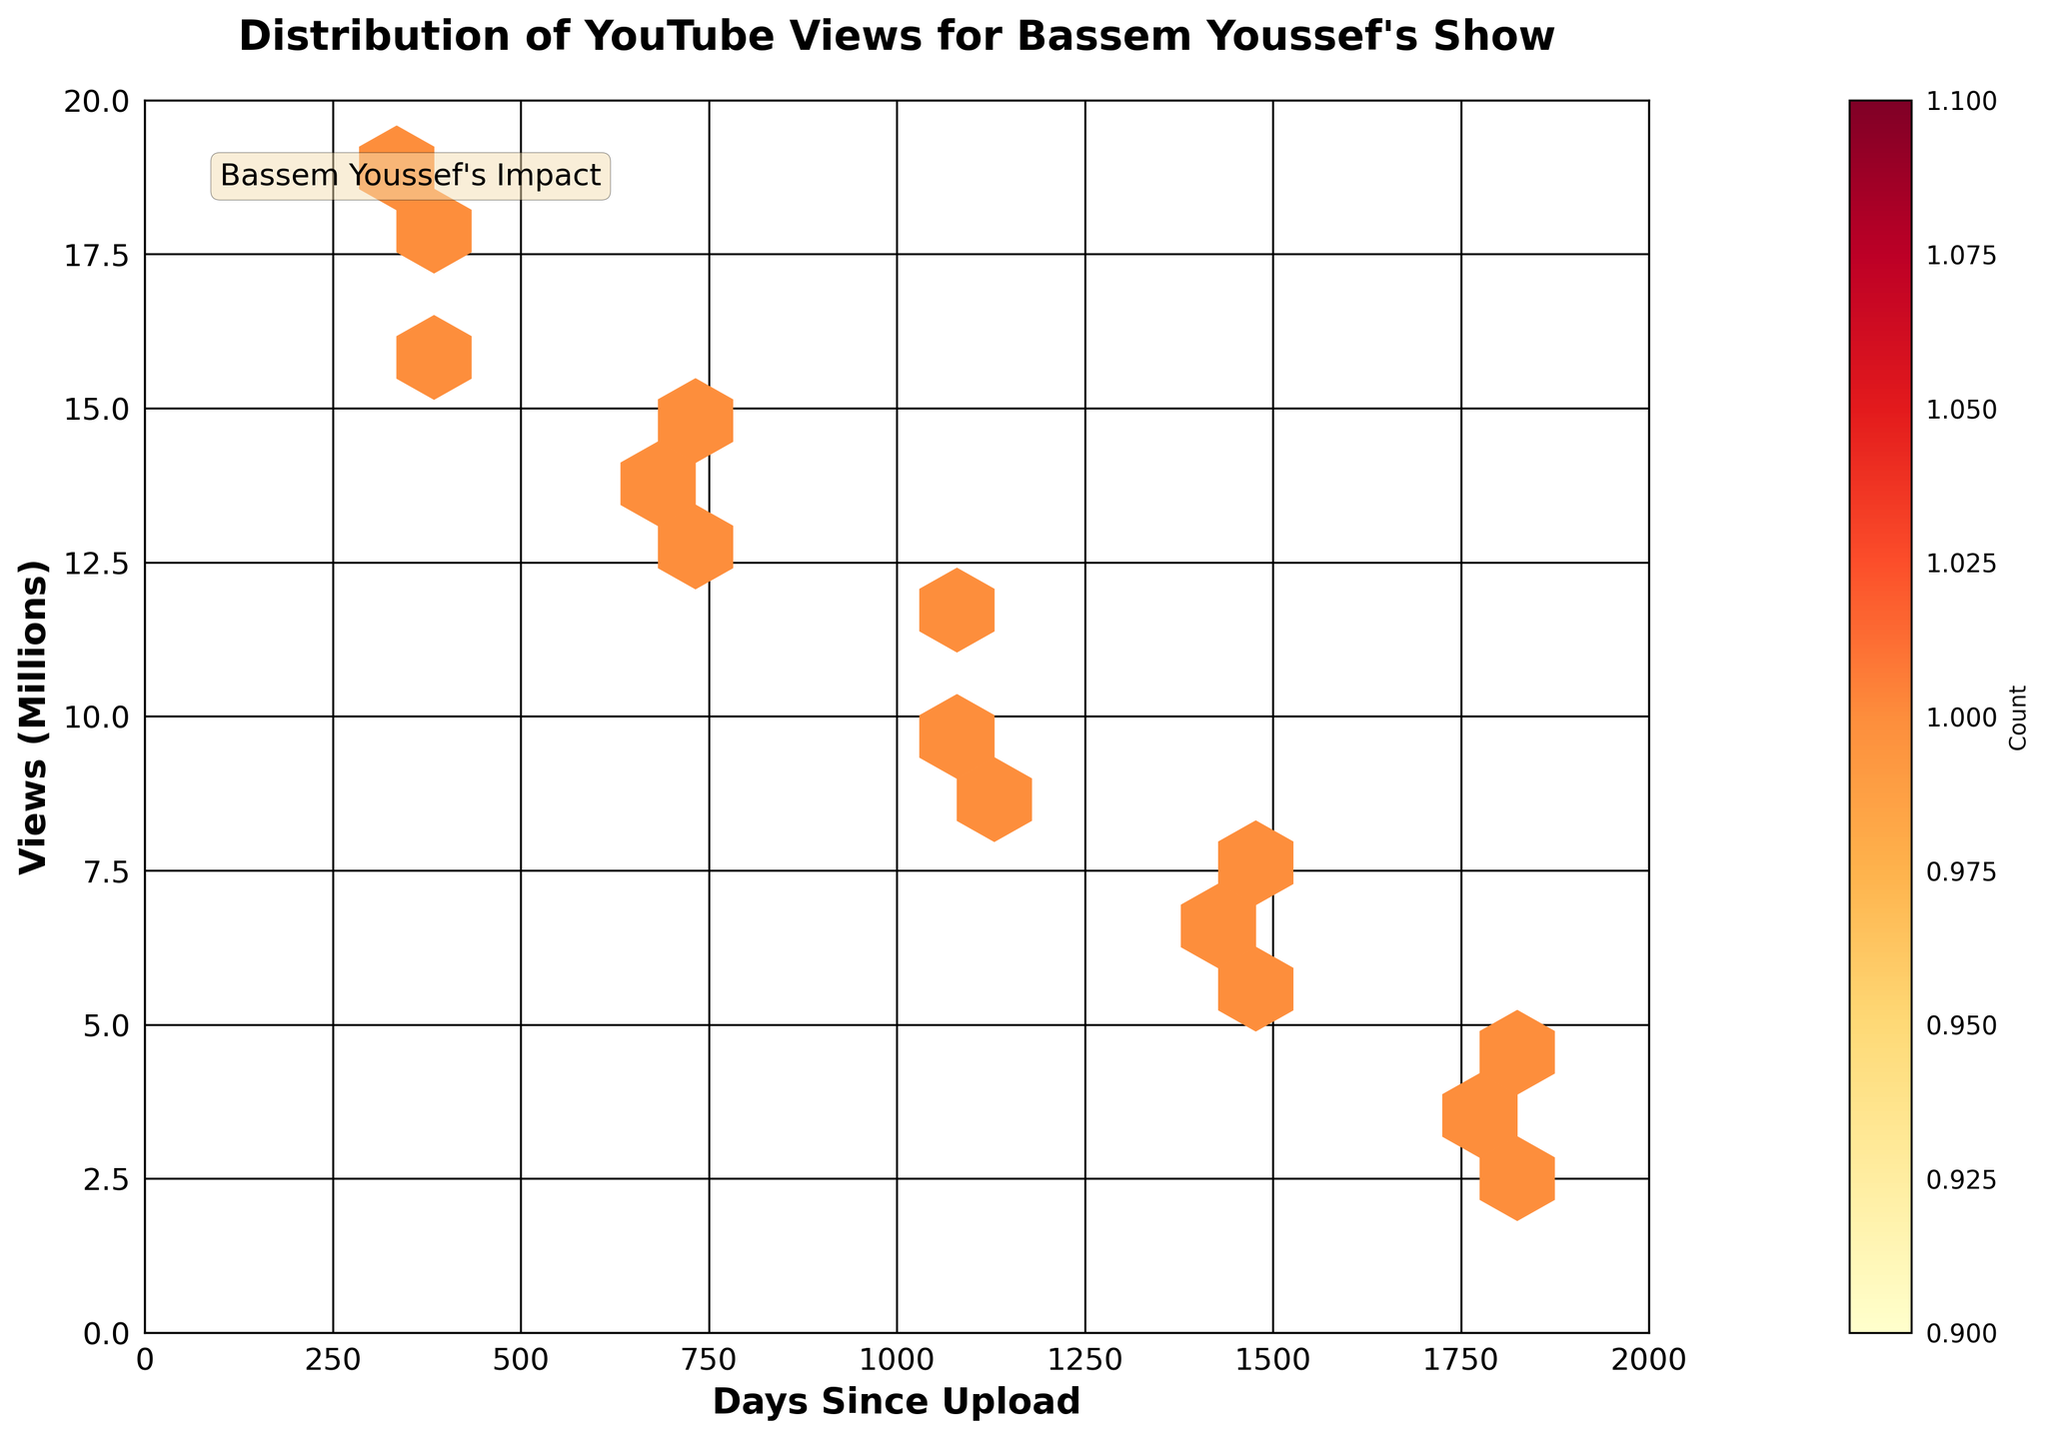What does the title of the plot say? The title of the plot is located at the top and provides a concise description of what the plot represents. It reads "Distribution of YouTube Views for Bassem Youssef's Show."
Answer: Distribution of YouTube Views for Bassem Youssef's Show What are the labels of the x and y axes? The labels of the x and y axes are located along the respective axes. The x-axis is labeled "Days Since Upload," and the y-axis is labeled "Views (Millions)."
Answer: Days Since Upload, Views (Millions) What does the color gradient on the plot represent? The color gradient on the hexbin plot indicates the density of data points in each hexagonal bin. It ranges from yellow, representing fewer points, to red, representing more points.
Answer: Density of data points Which season likely has episodes with the highest YouTube views? By observing the y-axis, we can see that the episodes with views ranging from 16.3 to 18.9 million are likely found in season 5, given the higher view numbers near the top of the plot.
Answer: Season 5 What is the range of the x-axis, and what does it signify? The x-axis ranges from 0 to 2000, which signifies the number of days since each episode was uploaded.
Answer: 0 to 2000 days Are there any clusters of episodes with similar views within the first 1000 days? By observing the plot, there are clusters of episodes with views between approximately 8.0 and 15.0 million views within the first 1000 days. This is signified by the dense regions of hexagons.
Answer: Yes Compare the YouTube view counts between episodes uploaded within the first 1000 days and those uploaded after 1500 days. The hexagons near the first 1000 days have higher views, ranging between 8.5 to 15 million, while hexagons after 1500 days generally show lower view counts around 2.5 to 4 million views.
Answer: Higher views between first 1000 days What does the annotation "Bassem Youssef's Impact" in the plot indicate? The annotation "Bassem Youssef's Impact" is likely meant to highlight an interesting aspect or to contextualize the data shown in the plot, emphasizing the influence of Bassem Youssef's show based on the views.
Answer: Bassem Youssef's influence How many bins (hexagons) are used in the plot, and why might this number be chosen? The plot uses a gridsize of 15 hexagons. A moderate number like this is often chosen to balance detail and readability, showing enough granularity without overcrowding.
Answer: 15 hexagons Is there a noticeable trend in the data based on the plot? Observing the plot, there's a noticeable trend where older episodes tend to have fewer views, while newer episodes, especially those within the last 1000 days, have higher views.
Answer: Newer episodes have higher views 